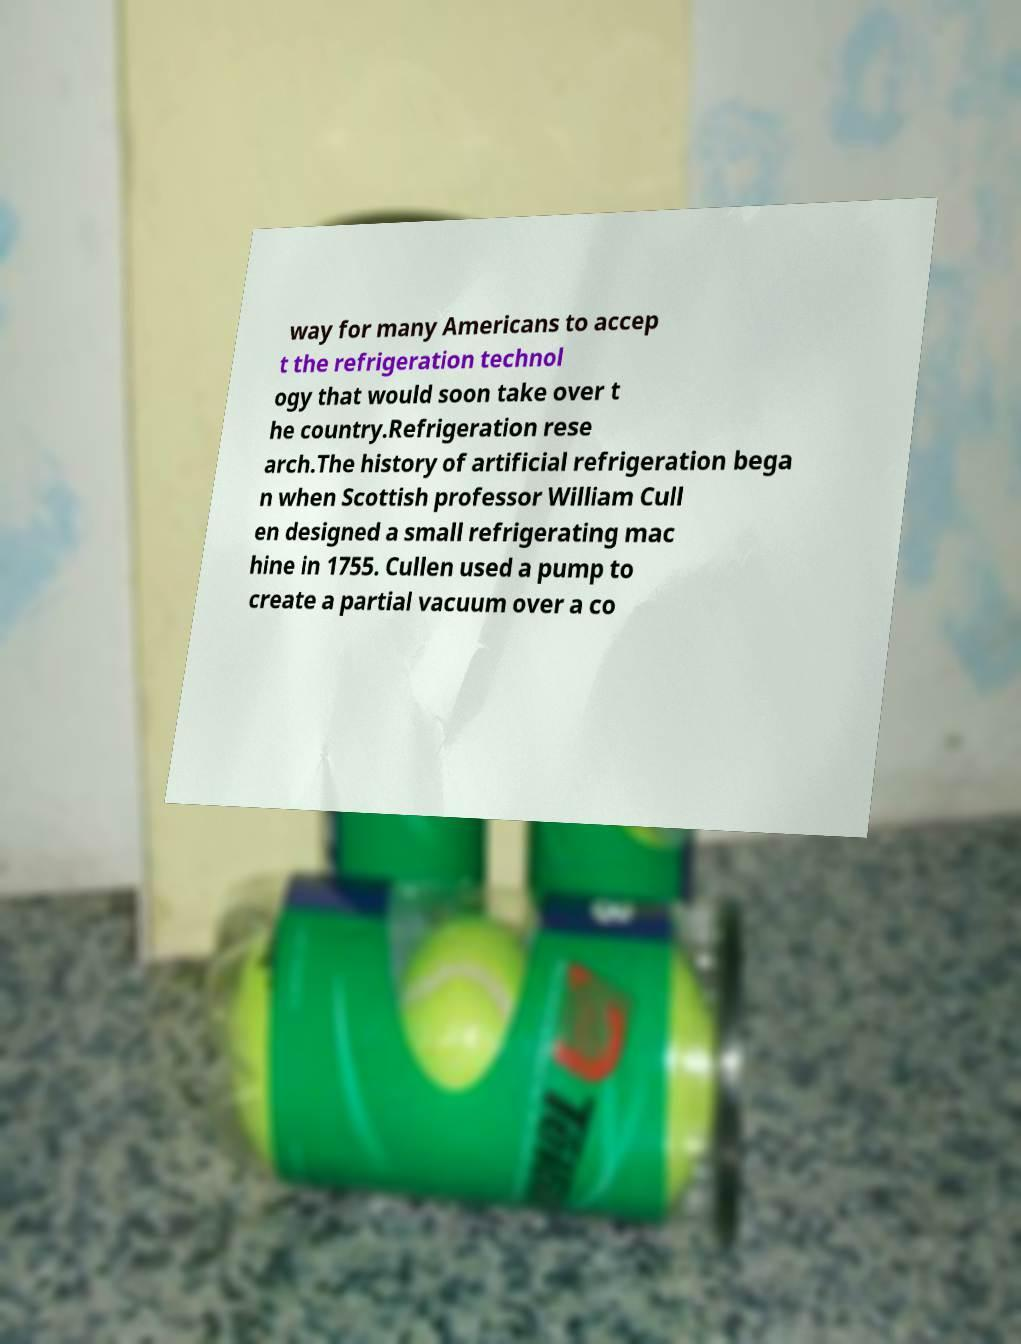Could you assist in decoding the text presented in this image and type it out clearly? way for many Americans to accep t the refrigeration technol ogy that would soon take over t he country.Refrigeration rese arch.The history of artificial refrigeration bega n when Scottish professor William Cull en designed a small refrigerating mac hine in 1755. Cullen used a pump to create a partial vacuum over a co 